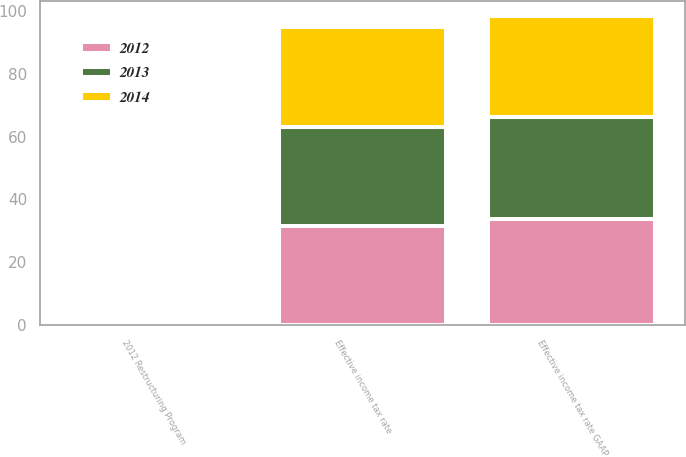<chart> <loc_0><loc_0><loc_500><loc_500><stacked_bar_chart><ecel><fcel>Effective income tax rate GAAP<fcel>2012 Restructuring Program<fcel>Effective income tax rate<nl><fcel>2012<fcel>33.8<fcel>0.5<fcel>31.5<nl><fcel>2013<fcel>32.4<fcel>0.7<fcel>31.7<nl><fcel>2014<fcel>32.1<fcel>0.3<fcel>31.8<nl></chart> 